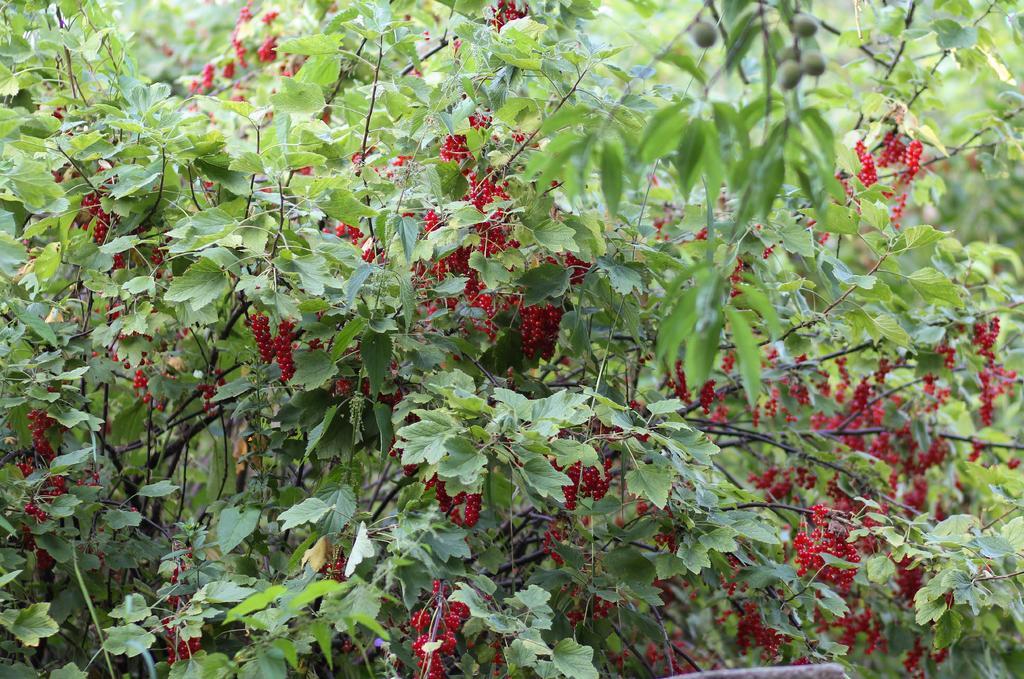Describe this image in one or two sentences. In this image there are plants, for that plants there are fruits. 